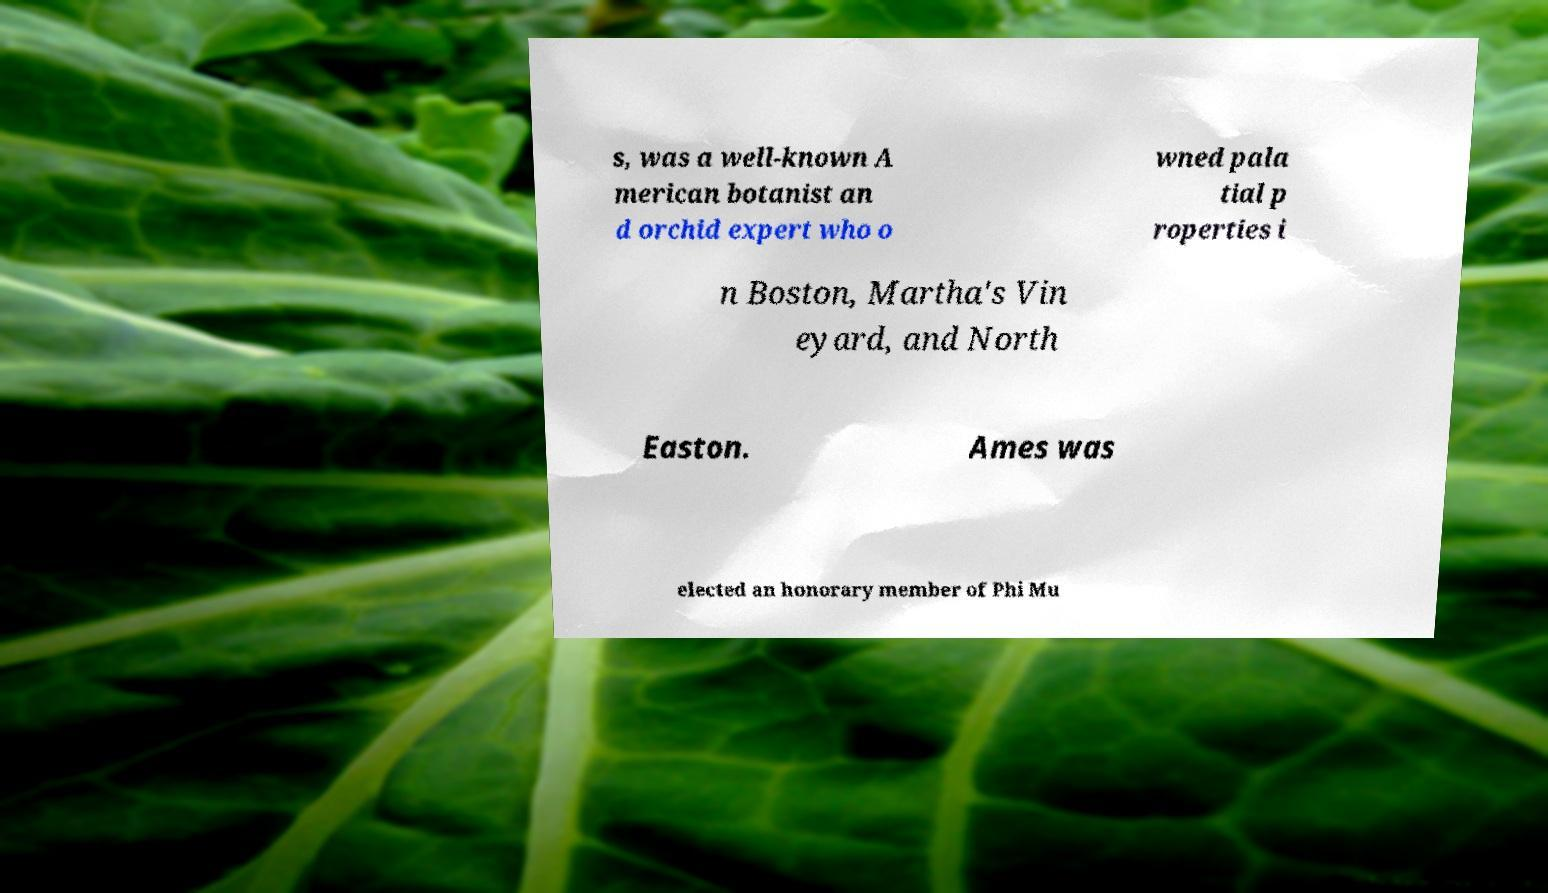Please identify and transcribe the text found in this image. s, was a well-known A merican botanist an d orchid expert who o wned pala tial p roperties i n Boston, Martha's Vin eyard, and North Easton. Ames was elected an honorary member of Phi Mu 